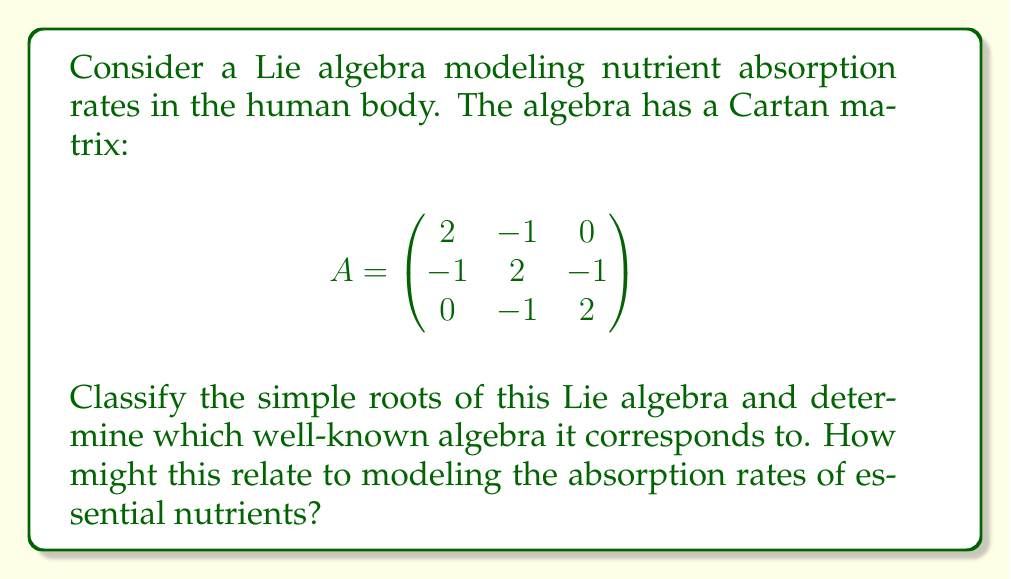Solve this math problem. 1) First, we need to analyze the Cartan matrix:
   - It's a 3x3 matrix, indicating a rank-3 Lie algebra.
   - It's symmetric and has 2's on the diagonal.
   - Off-diagonal elements are 0 or -1.

2) These properties suggest this is a simple Lie algebra.

3) To classify the simple roots, we need to construct the Dynkin diagram:
   - Each row/column represents a simple root.
   - If $A_{ij} = A_{ji} = -1$, we connect the nodes with a single line.
   - If $A_{ij} = A_{ji} = 0$, we don't connect the nodes.

4) The Dynkin diagram for this Cartan matrix is:

[asy]
unitsize(1cm);
dot((0,0)); dot((1,0)); dot((2,0));
draw((0,0)--(2,0));
label("$\alpha_1$", (0,-0.5));
label("$\alpha_2$", (1,-0.5));
label("$\alpha_3$", (2,-0.5));
[/asy]

5) This Dynkin diagram corresponds to the $A_3$ Lie algebra, which is isomorphic to $\mathfrak{sl}(4,\mathbb{C})$.

6) In the context of nutrient absorption rates:
   - Each simple root ($\alpha_1$, $\alpha_2$, $\alpha_3$) could represent a fundamental absorption process.
   - The connections in the Dynkin diagram might indicate interactions between these processes.
   - The $A_3$ structure suggests a linear chain of interactions, which could model sequential absorption steps or interdependent nutrient pathways.
Answer: $A_3$ Lie algebra (isomorphic to $\mathfrak{sl}(4,\mathbb{C})$) 